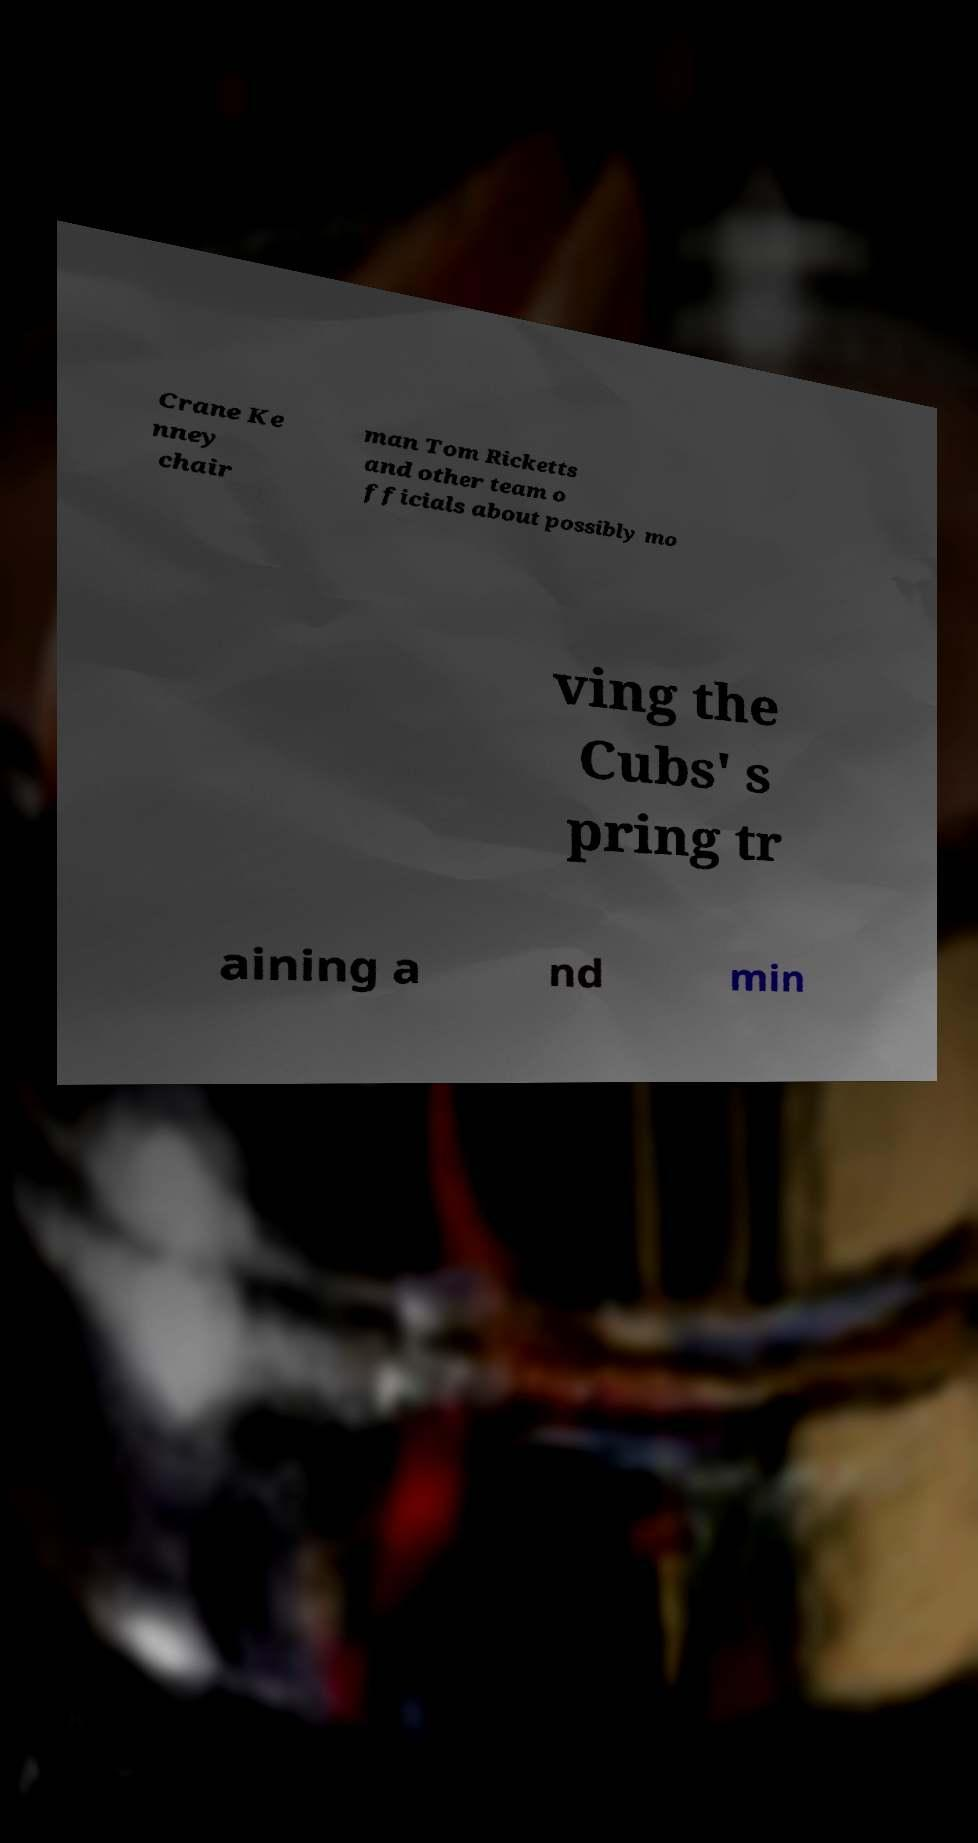Can you accurately transcribe the text from the provided image for me? Crane Ke nney chair man Tom Ricketts and other team o fficials about possibly mo ving the Cubs' s pring tr aining a nd min 